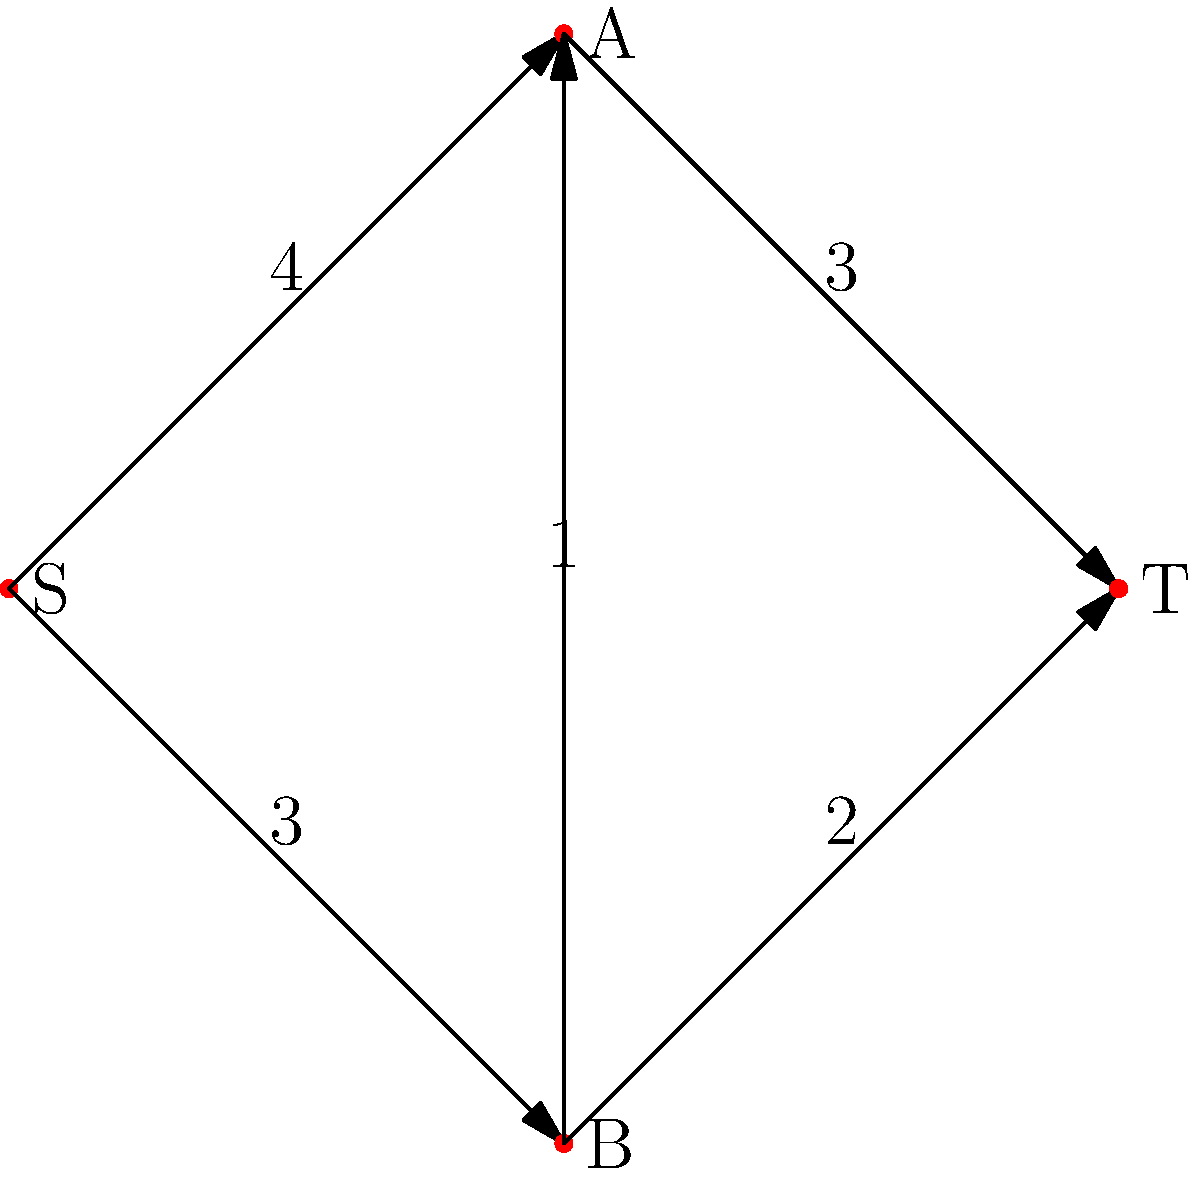During a highly anticipated match at the Maracanã Stadium in Rio de Janeiro, organizers want to maximize the flow of spectators through different entry points. The diagram represents the network of entry points, where S is the source (outside the stadium), T is the sink (inside the stadium), and A and B are intermediate checkpoints. The numbers on the edges represent the maximum number of thousands of spectators that can pass through each path per hour. What is the maximum number of spectators (in thousands) that can enter the stadium per hour? To solve this maximum flow problem, we'll use the Ford-Fulkerson algorithm:

1. Initialize flow to 0 for all edges.
2. Find an augmenting path from S to T:
   a. Path S-A-T: min(4,3) = 3
      Update flow: S-A: 3, A-T: 3
      Remaining capacity: S-A: 1, A-T: 0
   b. Path S-B-T: min(3,2) = 2
      Update flow: S-B: 2, B-T: 2
      Remaining capacity: S-B: 1, B-T: 0
   c. Path S-B-A-T: min(1,1,0) = 0
      No more augmenting paths

3. Calculate total flow:
   Flow into T = Flow from A to T + Flow from B to T
                = 3 + 2 = 5

Therefore, the maximum flow is 5,000 spectators per hour.
Answer: 5,000 spectators per hour 